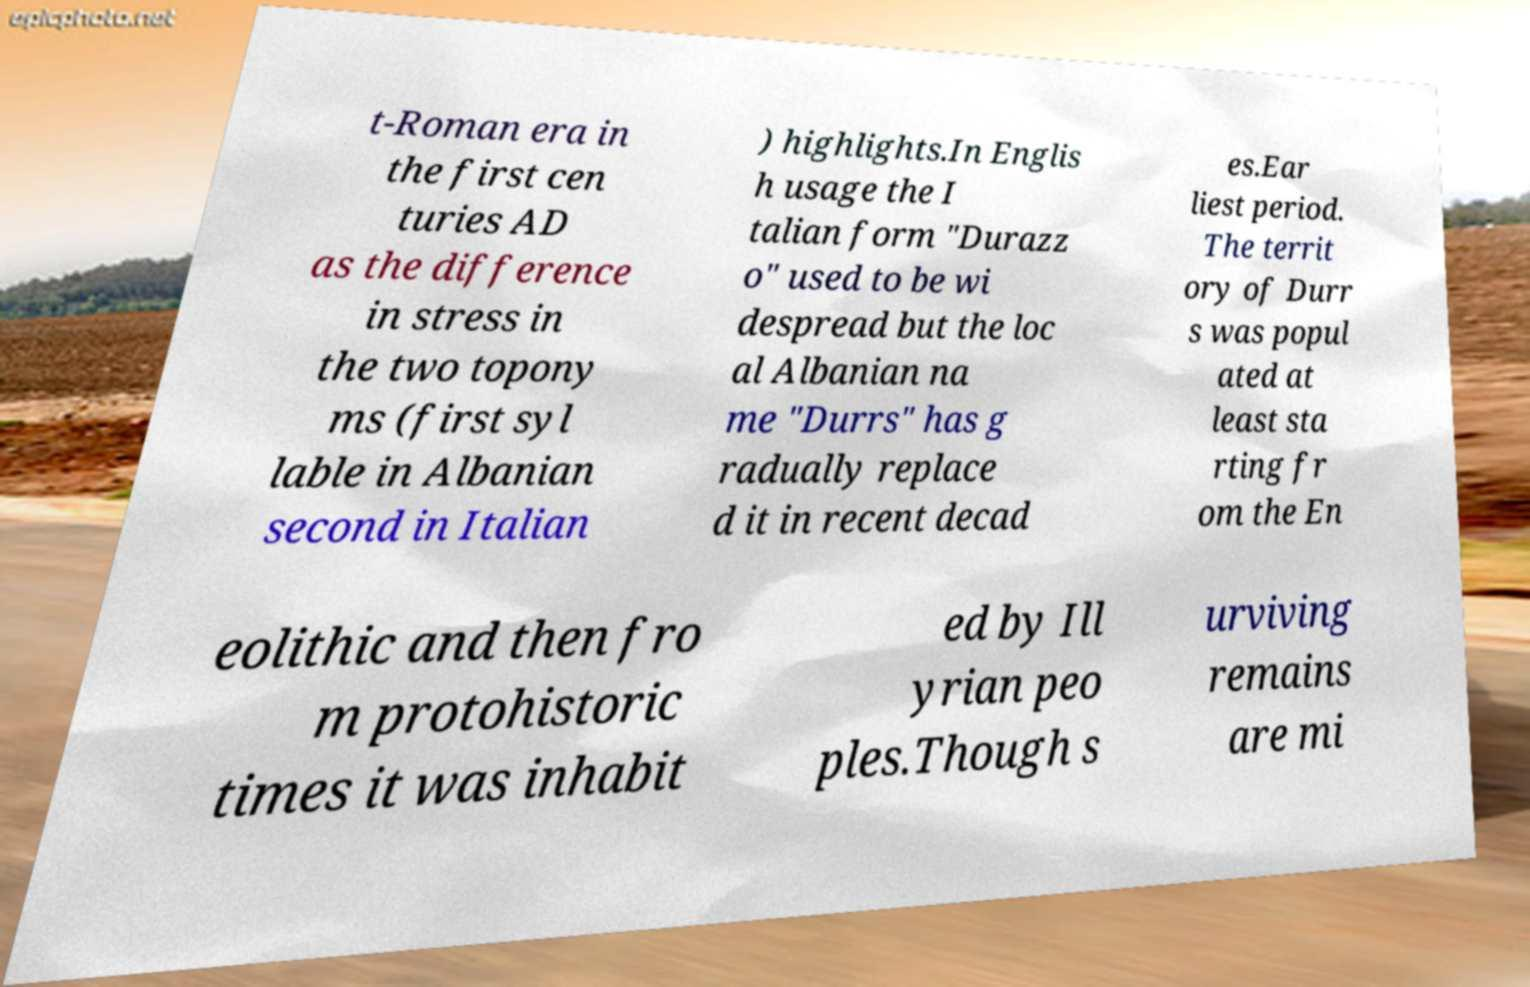What messages or text are displayed in this image? I need them in a readable, typed format. t-Roman era in the first cen turies AD as the difference in stress in the two topony ms (first syl lable in Albanian second in Italian ) highlights.In Englis h usage the I talian form "Durazz o" used to be wi despread but the loc al Albanian na me "Durrs" has g radually replace d it in recent decad es.Ear liest period. The territ ory of Durr s was popul ated at least sta rting fr om the En eolithic and then fro m protohistoric times it was inhabit ed by Ill yrian peo ples.Though s urviving remains are mi 